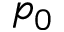<formula> <loc_0><loc_0><loc_500><loc_500>p _ { 0 }</formula> 